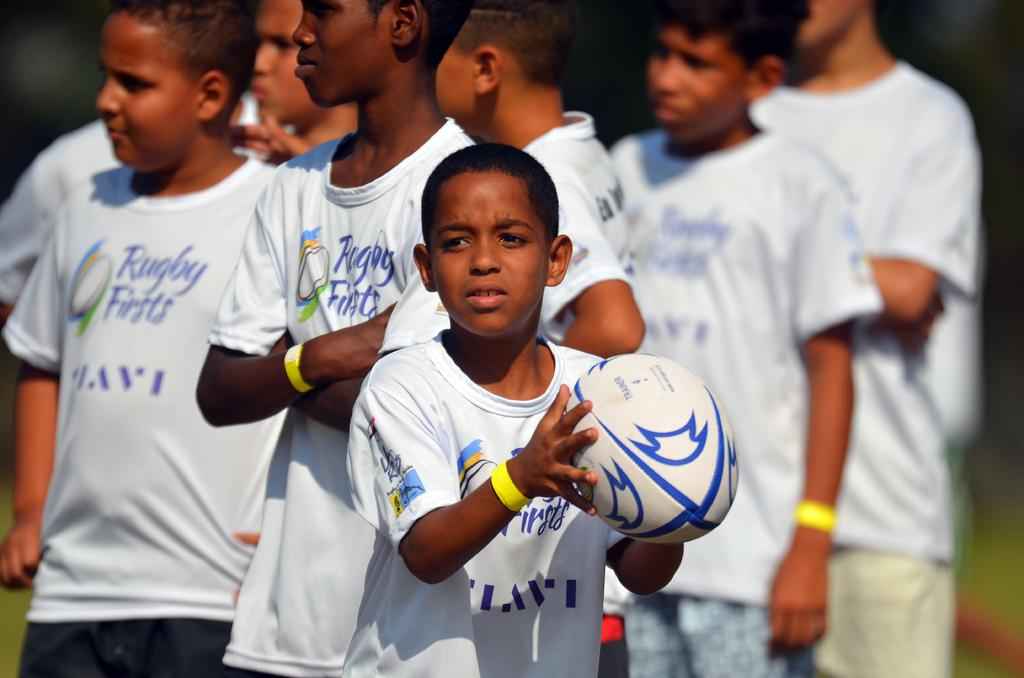What is the main subject of the image? The main subject of the image is a group of kids. How are the kids dressed in the image? The kids are wearing similar dress in the image. Can you describe the position of the kids in the image? There is a kid in the middle of the image, and the other kids are surrounding him. What is the kid in the middle doing? The kid in the middle is catching a ball in his hands. What color is the bun on the head of the kid in the middle? There is no bun visible on the head of the kid in the middle, and therefore no color can be determined. 